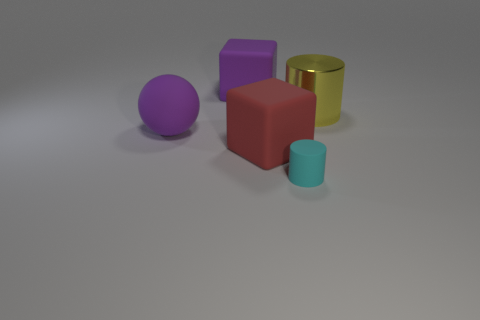Is there anything else that has the same size as the rubber cylinder?
Make the answer very short. No. There is a matte object on the right side of the red cube; is it the same size as the block behind the yellow cylinder?
Provide a short and direct response. No. How many balls are large shiny objects or big red objects?
Provide a succinct answer. 0. Are there any large red objects?
Your answer should be compact. Yes. Is there any other thing that is the same shape as the red matte object?
Ensure brevity in your answer.  Yes. Is the color of the ball the same as the small matte object?
Give a very brief answer. No. What number of things are either purple balls behind the small cyan cylinder or blue shiny cubes?
Your answer should be compact. 1. What number of rubber things are in front of the purple matte object in front of the large thing right of the tiny cylinder?
Offer a very short reply. 2. There is a purple object that is behind the thing that is to the left of the large purple rubber thing that is right of the matte sphere; what is its shape?
Your answer should be compact. Cube. What number of other objects are there of the same color as the large shiny object?
Ensure brevity in your answer.  0. 